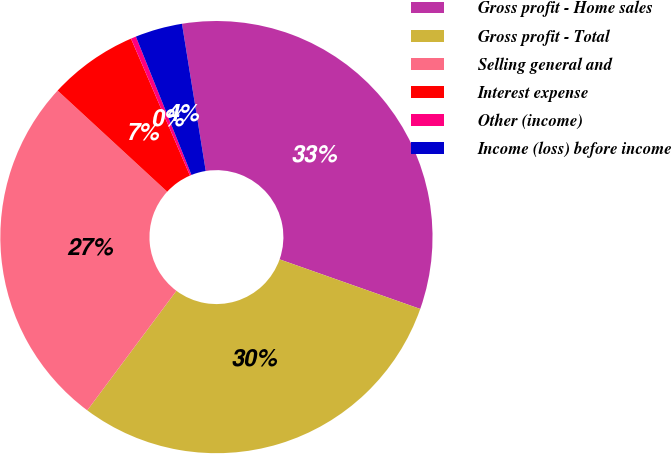Convert chart to OTSL. <chart><loc_0><loc_0><loc_500><loc_500><pie_chart><fcel>Gross profit - Home sales<fcel>Gross profit - Total<fcel>Selling general and<fcel>Interest expense<fcel>Other (income)<fcel>Income (loss) before income<nl><fcel>32.94%<fcel>29.8%<fcel>26.66%<fcel>6.67%<fcel>0.39%<fcel>3.53%<nl></chart> 